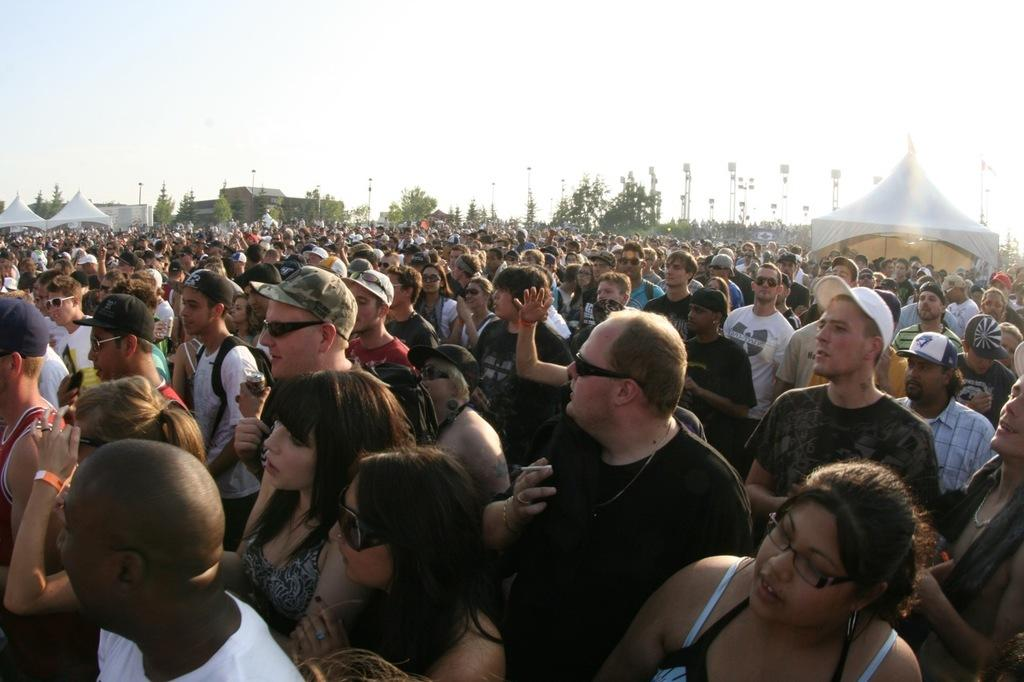What are the people in the image doing? The people in the image are standing on the ground. What are the people holding in their hands? The people are holding objects. What can be seen in the background of the image? There are tents, trees, towers, and the sky visible in the background. Can you see any cows in the image? There are no cows present in the image. What color are the people's eyes in the image? The image does not provide enough detail to determine the color of the people's eyes. 